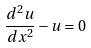Convert formula to latex. <formula><loc_0><loc_0><loc_500><loc_500>\frac { d ^ { 2 } u } { d x ^ { 2 } } - u = 0</formula> 